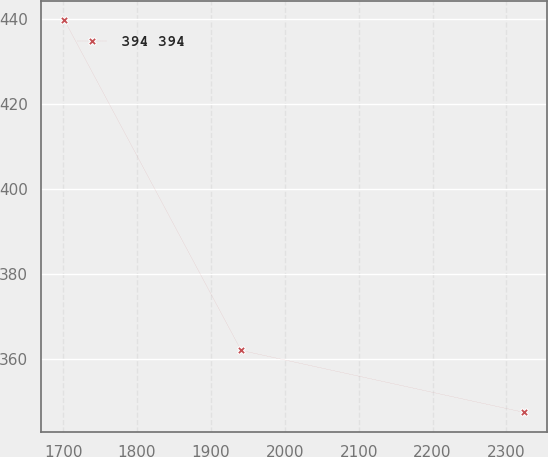Convert chart to OTSL. <chart><loc_0><loc_0><loc_500><loc_500><line_chart><ecel><fcel>394 394<nl><fcel>1701.68<fcel>439.81<nl><fcel>1940.89<fcel>361.99<nl><fcel>2323.42<fcel>347.4<nl></chart> 